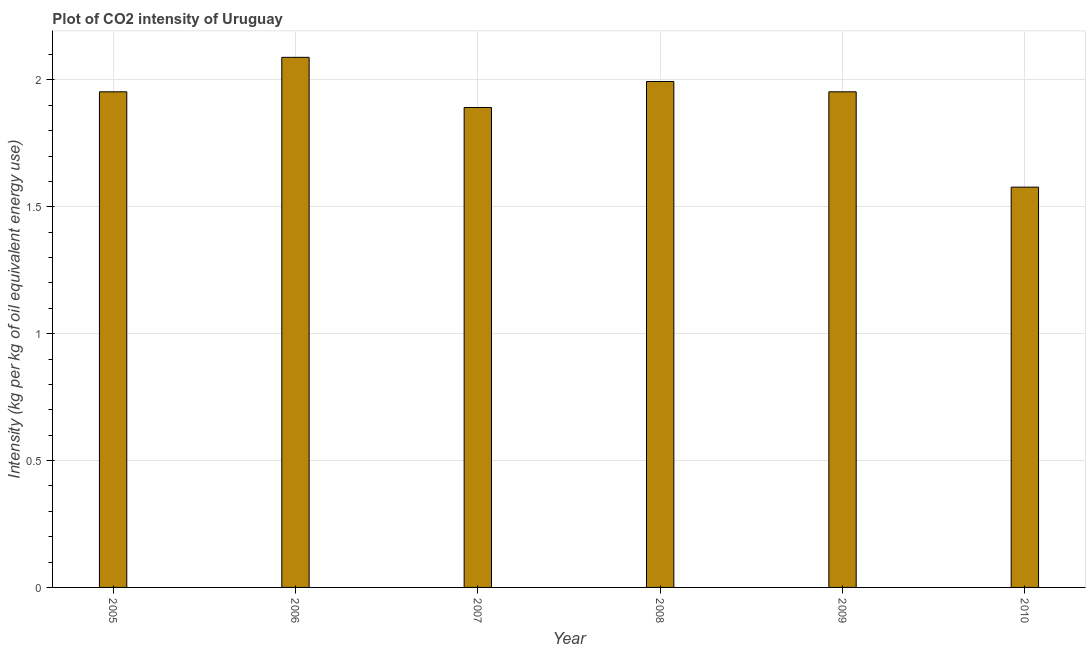Does the graph contain grids?
Make the answer very short. Yes. What is the title of the graph?
Offer a terse response. Plot of CO2 intensity of Uruguay. What is the label or title of the Y-axis?
Provide a succinct answer. Intensity (kg per kg of oil equivalent energy use). What is the co2 intensity in 2007?
Provide a short and direct response. 1.89. Across all years, what is the maximum co2 intensity?
Ensure brevity in your answer.  2.09. Across all years, what is the minimum co2 intensity?
Offer a very short reply. 1.58. What is the sum of the co2 intensity?
Offer a terse response. 11.46. What is the difference between the co2 intensity in 2005 and 2008?
Your answer should be very brief. -0.04. What is the average co2 intensity per year?
Keep it short and to the point. 1.91. What is the median co2 intensity?
Ensure brevity in your answer.  1.95. In how many years, is the co2 intensity greater than 1.6 kg?
Give a very brief answer. 5. What is the ratio of the co2 intensity in 2006 to that in 2008?
Give a very brief answer. 1.05. What is the difference between the highest and the second highest co2 intensity?
Ensure brevity in your answer.  0.1. What is the difference between the highest and the lowest co2 intensity?
Your answer should be compact. 0.51. How many bars are there?
Offer a terse response. 6. Are all the bars in the graph horizontal?
Your response must be concise. No. Are the values on the major ticks of Y-axis written in scientific E-notation?
Your answer should be very brief. No. What is the Intensity (kg per kg of oil equivalent energy use) of 2005?
Provide a short and direct response. 1.95. What is the Intensity (kg per kg of oil equivalent energy use) of 2006?
Offer a very short reply. 2.09. What is the Intensity (kg per kg of oil equivalent energy use) in 2007?
Ensure brevity in your answer.  1.89. What is the Intensity (kg per kg of oil equivalent energy use) of 2008?
Provide a short and direct response. 1.99. What is the Intensity (kg per kg of oil equivalent energy use) in 2009?
Make the answer very short. 1.95. What is the Intensity (kg per kg of oil equivalent energy use) of 2010?
Provide a short and direct response. 1.58. What is the difference between the Intensity (kg per kg of oil equivalent energy use) in 2005 and 2006?
Keep it short and to the point. -0.14. What is the difference between the Intensity (kg per kg of oil equivalent energy use) in 2005 and 2007?
Your response must be concise. 0.06. What is the difference between the Intensity (kg per kg of oil equivalent energy use) in 2005 and 2008?
Make the answer very short. -0.04. What is the difference between the Intensity (kg per kg of oil equivalent energy use) in 2005 and 2009?
Ensure brevity in your answer.  5e-5. What is the difference between the Intensity (kg per kg of oil equivalent energy use) in 2005 and 2010?
Make the answer very short. 0.38. What is the difference between the Intensity (kg per kg of oil equivalent energy use) in 2006 and 2007?
Ensure brevity in your answer.  0.2. What is the difference between the Intensity (kg per kg of oil equivalent energy use) in 2006 and 2008?
Keep it short and to the point. 0.1. What is the difference between the Intensity (kg per kg of oil equivalent energy use) in 2006 and 2009?
Your answer should be very brief. 0.14. What is the difference between the Intensity (kg per kg of oil equivalent energy use) in 2006 and 2010?
Offer a very short reply. 0.51. What is the difference between the Intensity (kg per kg of oil equivalent energy use) in 2007 and 2008?
Your answer should be very brief. -0.1. What is the difference between the Intensity (kg per kg of oil equivalent energy use) in 2007 and 2009?
Provide a short and direct response. -0.06. What is the difference between the Intensity (kg per kg of oil equivalent energy use) in 2007 and 2010?
Keep it short and to the point. 0.31. What is the difference between the Intensity (kg per kg of oil equivalent energy use) in 2008 and 2009?
Keep it short and to the point. 0.04. What is the difference between the Intensity (kg per kg of oil equivalent energy use) in 2008 and 2010?
Offer a terse response. 0.42. What is the difference between the Intensity (kg per kg of oil equivalent energy use) in 2009 and 2010?
Offer a very short reply. 0.38. What is the ratio of the Intensity (kg per kg of oil equivalent energy use) in 2005 to that in 2006?
Give a very brief answer. 0.94. What is the ratio of the Intensity (kg per kg of oil equivalent energy use) in 2005 to that in 2007?
Provide a succinct answer. 1.03. What is the ratio of the Intensity (kg per kg of oil equivalent energy use) in 2005 to that in 2010?
Your answer should be compact. 1.24. What is the ratio of the Intensity (kg per kg of oil equivalent energy use) in 2006 to that in 2007?
Your answer should be very brief. 1.1. What is the ratio of the Intensity (kg per kg of oil equivalent energy use) in 2006 to that in 2008?
Keep it short and to the point. 1.05. What is the ratio of the Intensity (kg per kg of oil equivalent energy use) in 2006 to that in 2009?
Your response must be concise. 1.07. What is the ratio of the Intensity (kg per kg of oil equivalent energy use) in 2006 to that in 2010?
Your answer should be compact. 1.32. What is the ratio of the Intensity (kg per kg of oil equivalent energy use) in 2007 to that in 2008?
Offer a very short reply. 0.95. What is the ratio of the Intensity (kg per kg of oil equivalent energy use) in 2007 to that in 2009?
Ensure brevity in your answer.  0.97. What is the ratio of the Intensity (kg per kg of oil equivalent energy use) in 2007 to that in 2010?
Ensure brevity in your answer.  1.2. What is the ratio of the Intensity (kg per kg of oil equivalent energy use) in 2008 to that in 2009?
Provide a short and direct response. 1.02. What is the ratio of the Intensity (kg per kg of oil equivalent energy use) in 2008 to that in 2010?
Your answer should be very brief. 1.26. What is the ratio of the Intensity (kg per kg of oil equivalent energy use) in 2009 to that in 2010?
Your answer should be very brief. 1.24. 